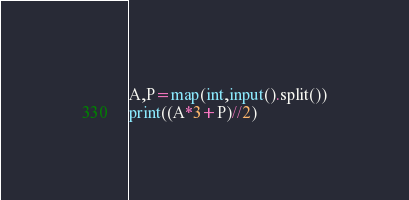Convert code to text. <code><loc_0><loc_0><loc_500><loc_500><_Python_>A,P=map(int,input().split())
print((A*3+P)//2)
</code> 